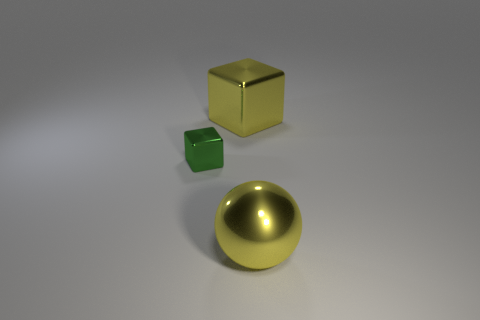Add 2 large matte things. How many objects exist? 5 Subtract all green cubes. How many cubes are left? 1 Subtract 0 blue spheres. How many objects are left? 3 Subtract all spheres. How many objects are left? 2 Subtract all yellow blocks. Subtract all gray spheres. How many blocks are left? 1 Subtract all red cylinders. How many purple spheres are left? 0 Subtract all green matte balls. Subtract all big yellow spheres. How many objects are left? 2 Add 2 tiny green metal things. How many tiny green metal things are left? 3 Add 1 cubes. How many cubes exist? 3 